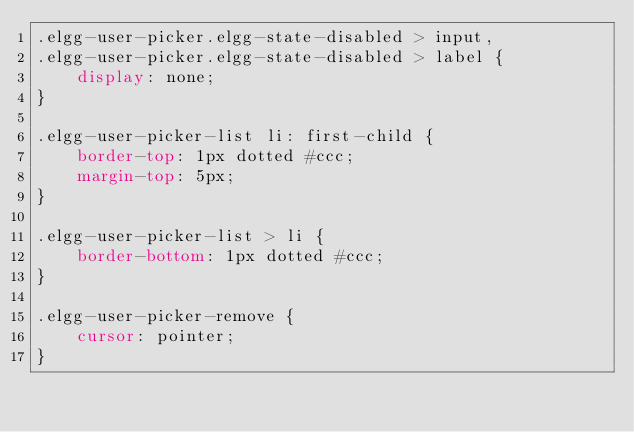<code> <loc_0><loc_0><loc_500><loc_500><_CSS_>.elgg-user-picker.elgg-state-disabled > input,
.elgg-user-picker.elgg-state-disabled > label {
	display: none;
}

.elgg-user-picker-list li: first-child {
	border-top: 1px dotted #ccc;
	margin-top: 5px;
}

.elgg-user-picker-list > li {
	border-bottom: 1px dotted #ccc;
}

.elgg-user-picker-remove {
	cursor: pointer;
}</code> 